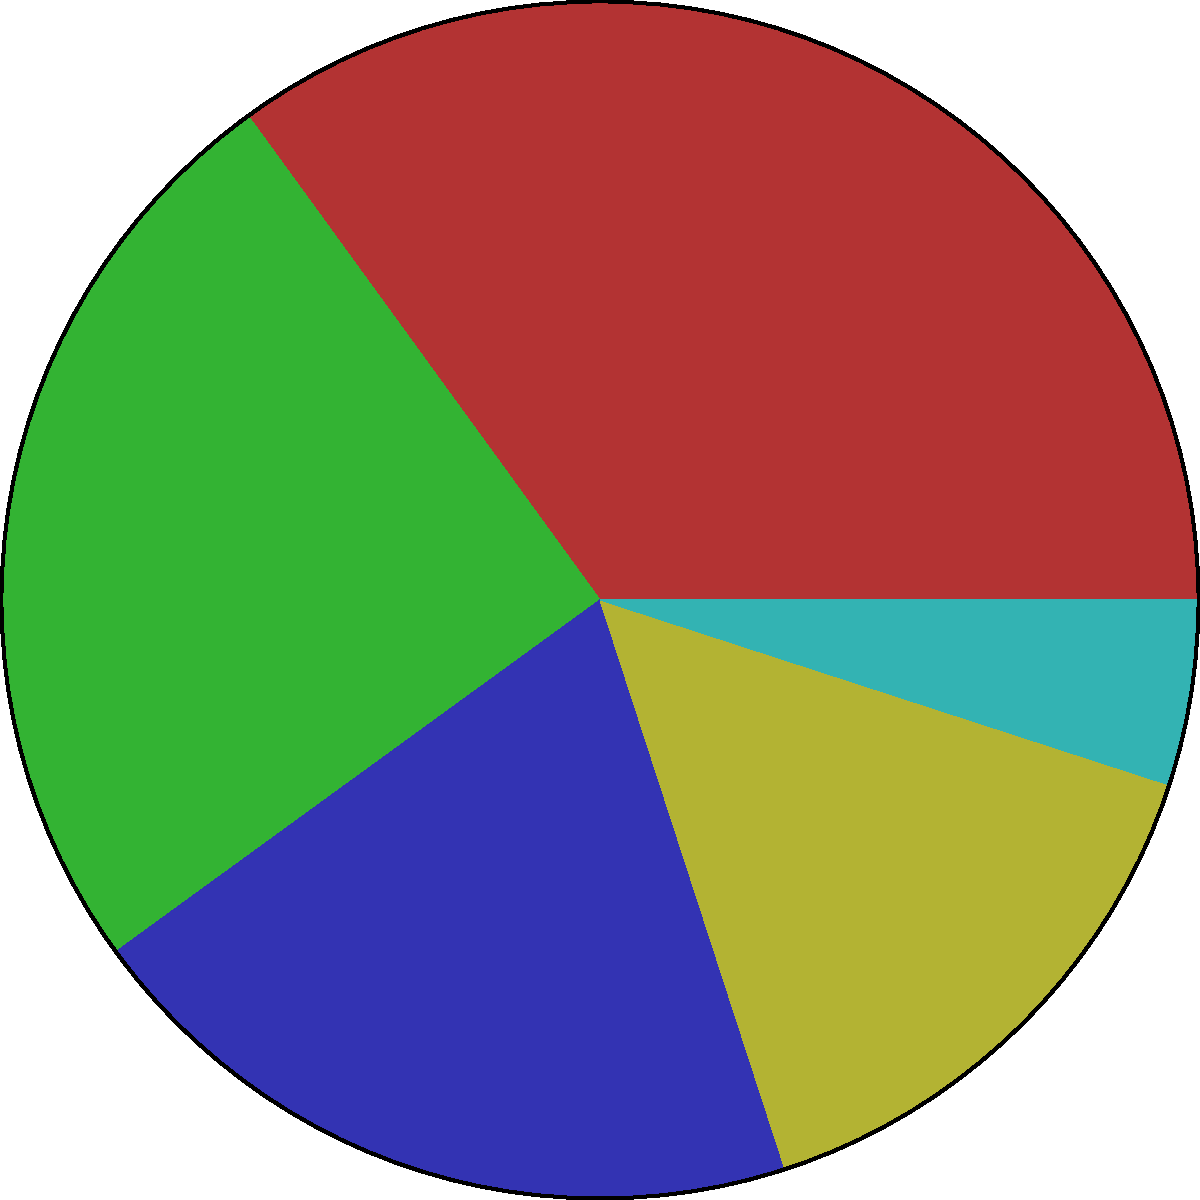In a pie chart representing the distribution of archival document types in a digital humanities project, the sector for "Photographs" covers 25% of the total area. What is the central angle of this sector in degrees? To determine the central angle of a sector in a pie chart, we need to follow these steps:

1. Understand the relationship between percentage and central angle:
   - A complete circle has 360°
   - The percentage of the total represented by a sector is proportional to its central angle

2. Set up the proportion:
   Let $x$ be the central angle we're looking for.
   $$\frac{\text{Sector Percentage}}{100\%} = \frac{x}{360°}$$

3. Plug in the known values:
   $$\frac{25\%}{100\%} = \frac{x}{360°}$$

4. Solve for $x$:
   $$x = 360° \times \frac{25}{100} = 360° \times 0.25 = 90°$$

Therefore, the central angle of the "Photographs" sector is 90°.
Answer: 90° 